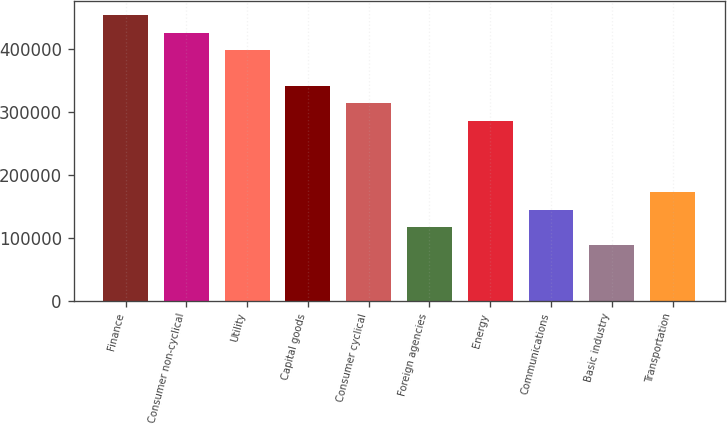<chart> <loc_0><loc_0><loc_500><loc_500><bar_chart><fcel>Finance<fcel>Consumer non-cyclical<fcel>Utility<fcel>Capital goods<fcel>Consumer cyclical<fcel>Foreign agencies<fcel>Energy<fcel>Communications<fcel>Basic industry<fcel>Transportation<nl><fcel>453406<fcel>425305<fcel>397204<fcel>341001<fcel>312900<fcel>116192<fcel>284799<fcel>144293<fcel>88090.6<fcel>172394<nl></chart> 